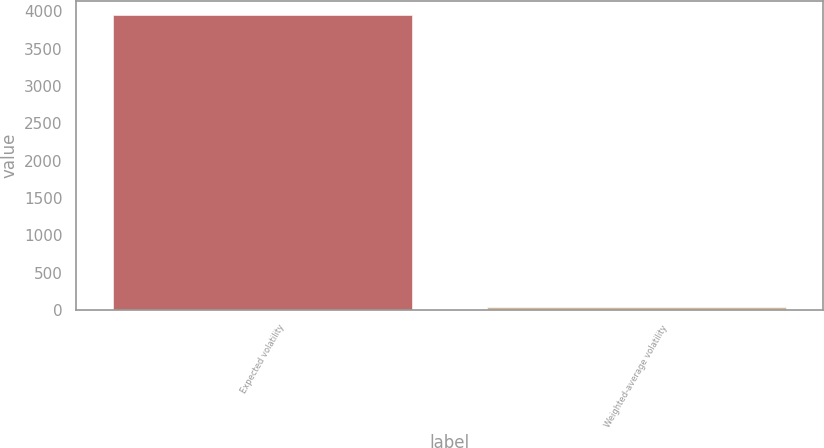<chart> <loc_0><loc_0><loc_500><loc_500><bar_chart><fcel>Expected volatility<fcel>Weighted-average volatility<nl><fcel>3945<fcel>42<nl></chart> 